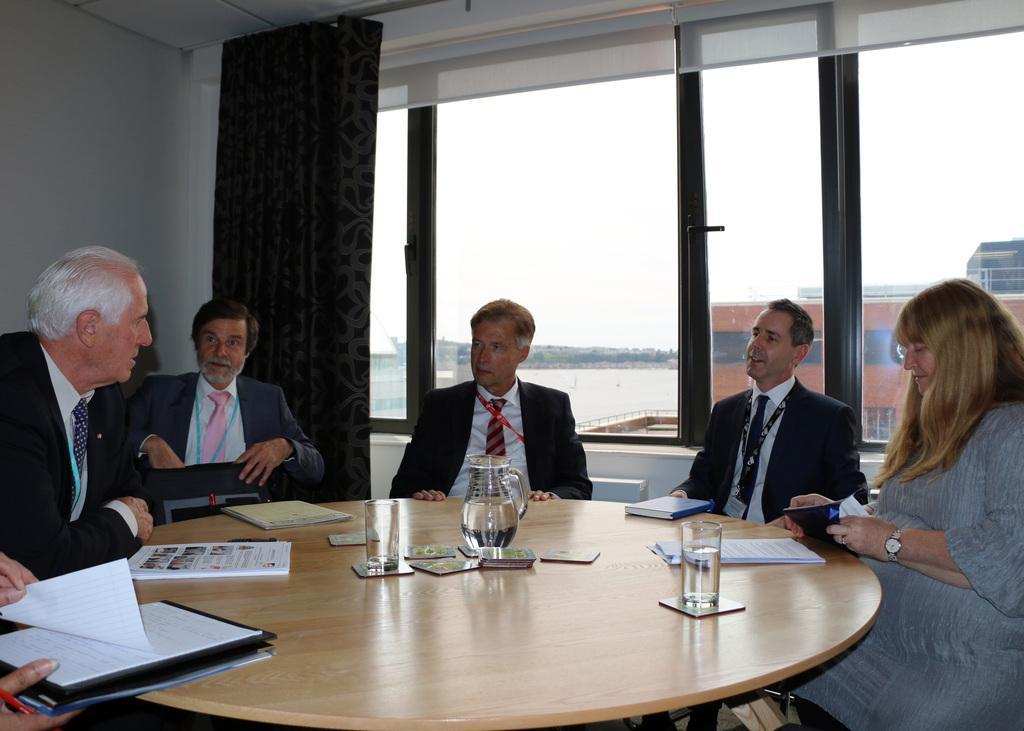How would you summarize this image in a sentence or two? As we can see in the image there is a white color wall, curtain, window, water, few people sitting on chairs and there is a table. On table there is a file, book, papers, glass and mug. 